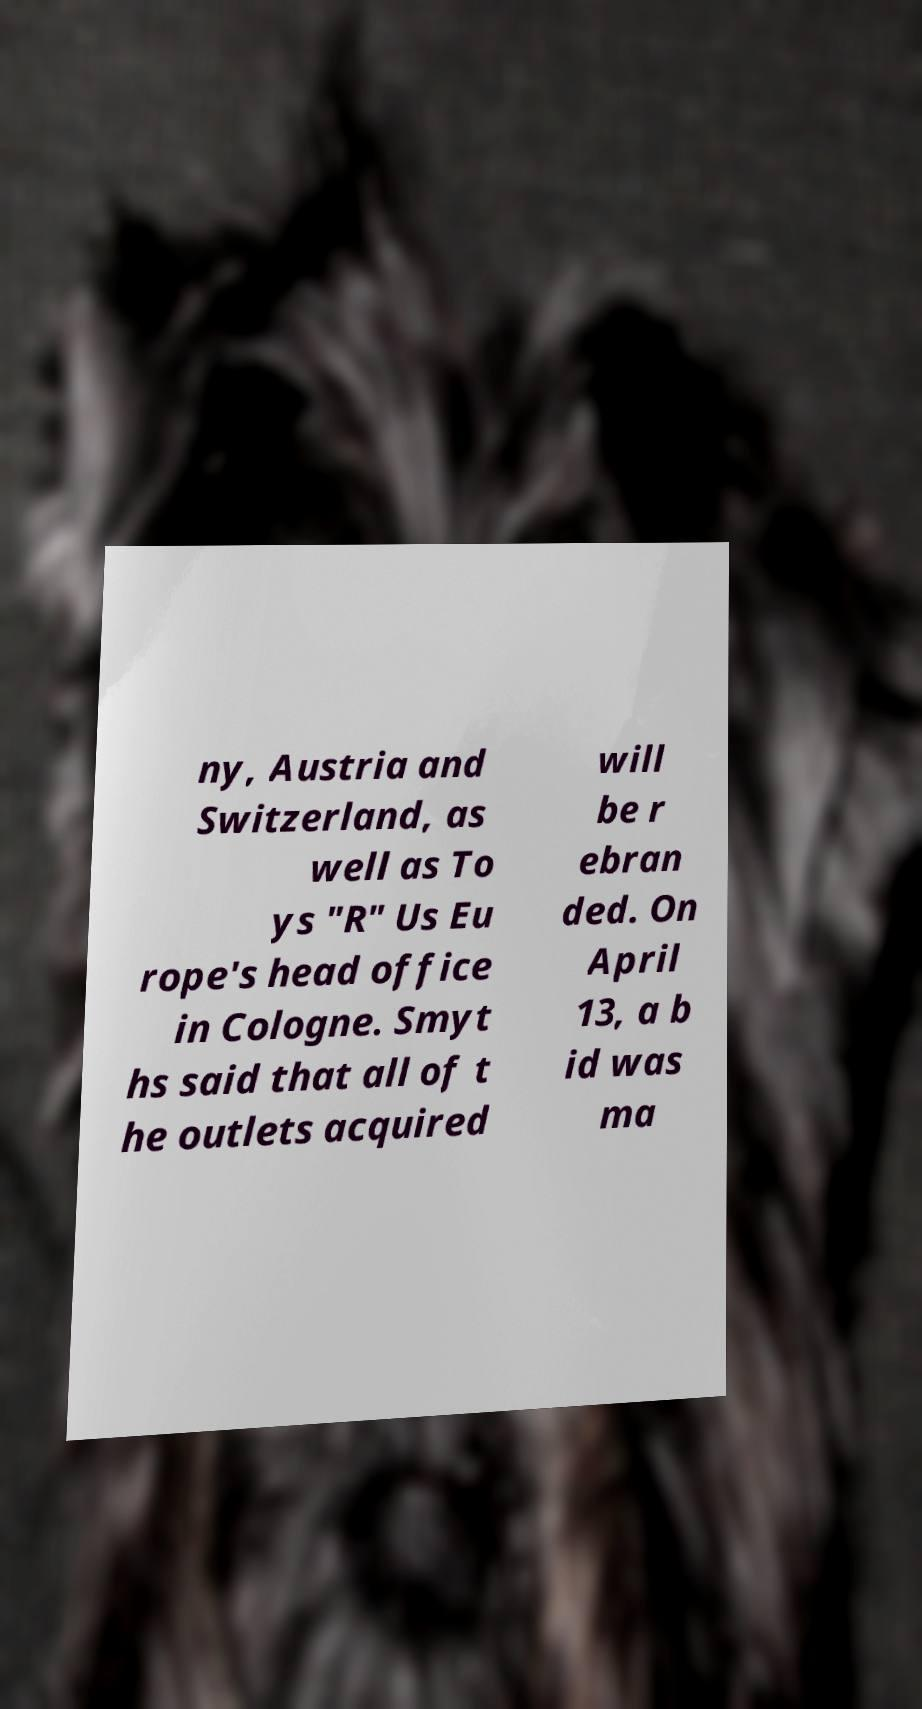Can you read and provide the text displayed in the image?This photo seems to have some interesting text. Can you extract and type it out for me? ny, Austria and Switzerland, as well as To ys "R" Us Eu rope's head office in Cologne. Smyt hs said that all of t he outlets acquired will be r ebran ded. On April 13, a b id was ma 